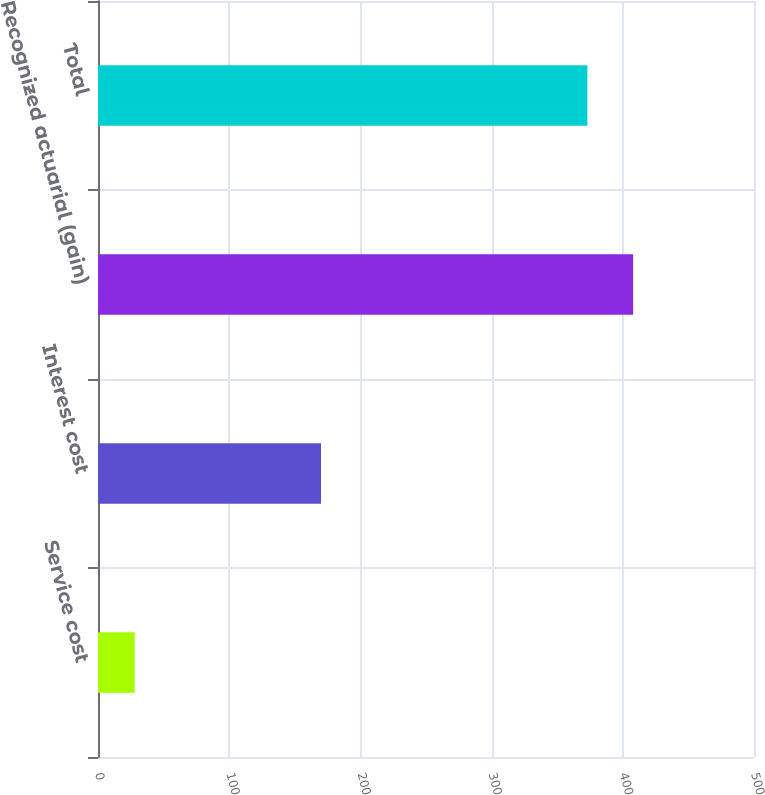Convert chart. <chart><loc_0><loc_0><loc_500><loc_500><bar_chart><fcel>Service cost<fcel>Interest cost<fcel>Recognized actuarial (gain)<fcel>Total<nl><fcel>28<fcel>170<fcel>407.9<fcel>373<nl></chart> 